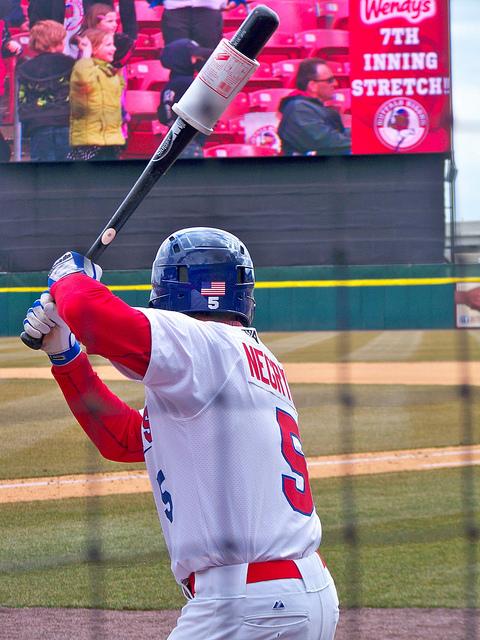Which inning is the stretch?
Short answer required. 7th. What is the player's uniform number?
Quick response, please. 5. Is the batter at bat?
Keep it brief. Yes. 